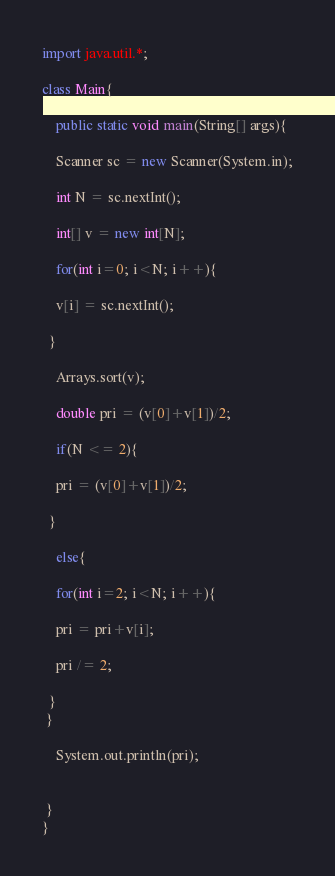<code> <loc_0><loc_0><loc_500><loc_500><_Java_>import java.util.*;
 
class Main{
 
    public static void main(String[] args){
 
	Scanner sc = new Scanner(System.in);
 
	int N = sc.nextInt();
 
	int[] v = new int[N];
 
	for(int i=0; i<N; i++){
 
	v[i] = sc.nextInt();
 
  }
 
	Arrays.sort(v);
 
	double pri = (v[0]+v[1])/2;
 
	if(N <= 2){
 
	pri = (v[0]+v[1])/2;
 
  }
 
	else{	
 
	for(int i=2; i<N; i++){
 
	pri = pri+v[i];
 
	pri /= 2;
 
  }
 }
 
	System.out.println(pri);
 
 
 }
}</code> 